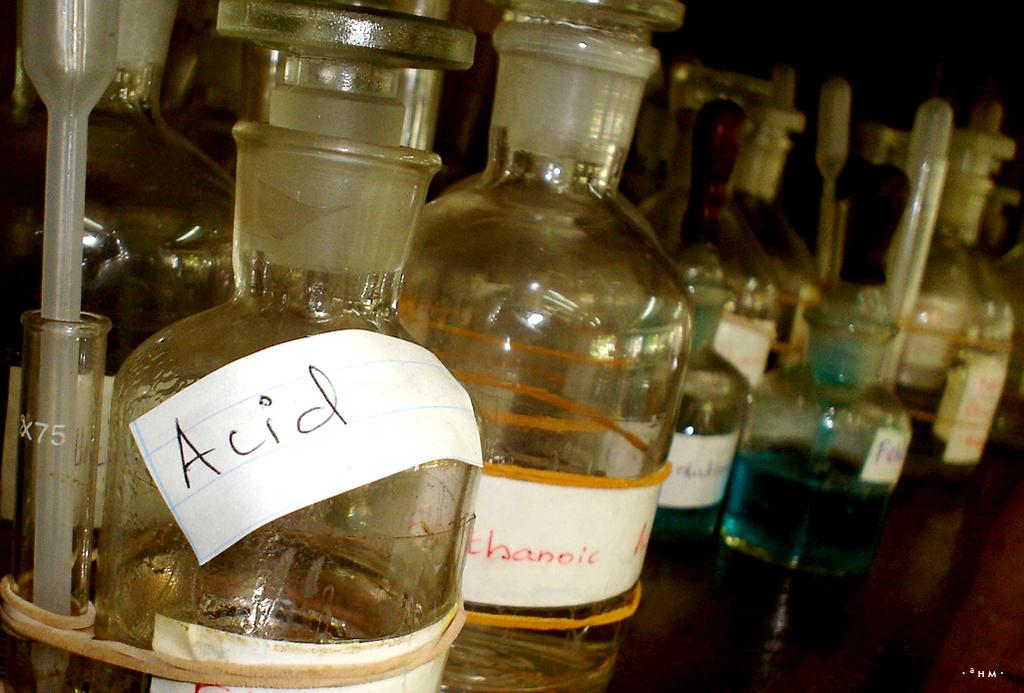<image>
Create a compact narrative representing the image presented. Someone has labeled a bottle of Acid with a paper label. 